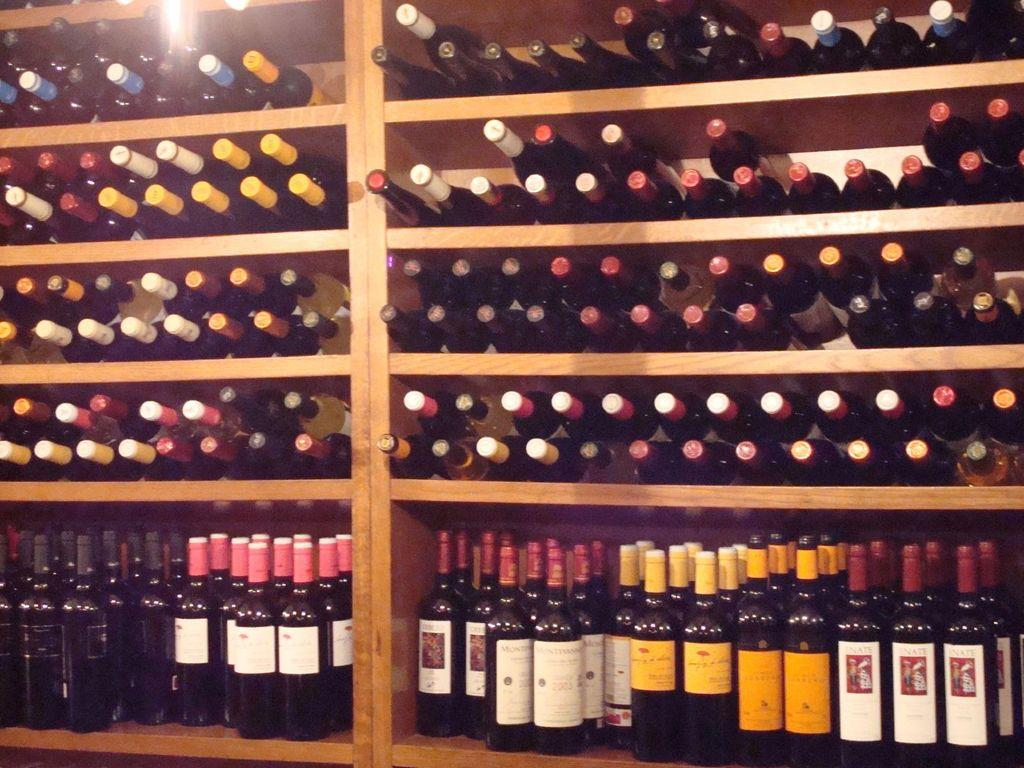What is the main subject of the image? The main subject of the image is a wine shelf. How many wine bottles can be seen on the wine shelf? The wine shelf has many wine bottles placed in it. What type of soap is being used to clean the wine bottles in the image? There is no soap or cleaning activity present in the image; it only features a wine shelf with wine bottles. How does the wine shelf kick the soccer ball in the image? The wine shelf does not kick a soccer ball in the image; it is an inanimate object. 